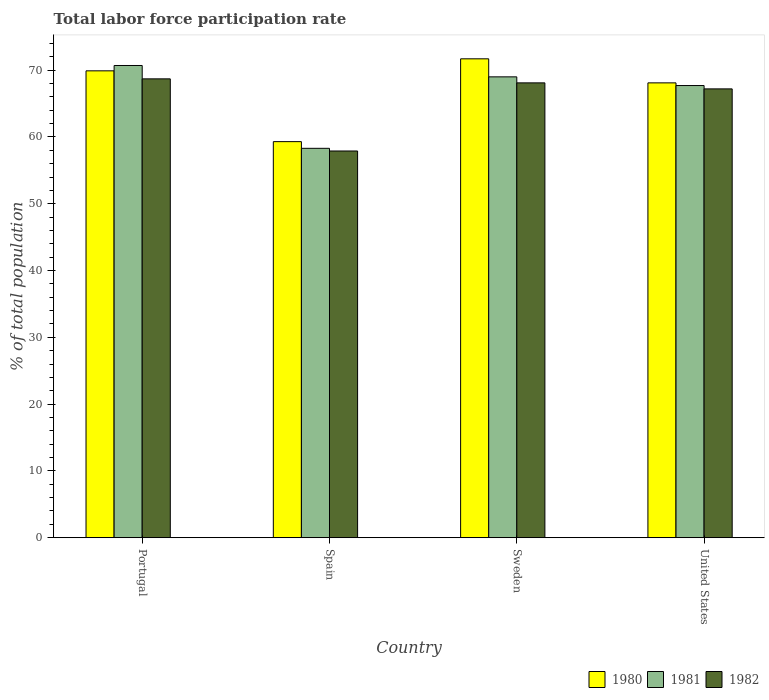How many bars are there on the 4th tick from the right?
Keep it short and to the point. 3. What is the label of the 2nd group of bars from the left?
Your response must be concise. Spain. What is the total labor force participation rate in 1980 in Portugal?
Offer a terse response. 69.9. Across all countries, what is the maximum total labor force participation rate in 1980?
Offer a very short reply. 71.7. Across all countries, what is the minimum total labor force participation rate in 1980?
Keep it short and to the point. 59.3. In which country was the total labor force participation rate in 1980 minimum?
Your answer should be compact. Spain. What is the total total labor force participation rate in 1981 in the graph?
Give a very brief answer. 265.7. What is the difference between the total labor force participation rate in 1980 in Sweden and that in United States?
Make the answer very short. 3.6. What is the difference between the total labor force participation rate in 1980 in Portugal and the total labor force participation rate in 1982 in United States?
Provide a succinct answer. 2.7. What is the average total labor force participation rate in 1981 per country?
Make the answer very short. 66.42. What is the difference between the total labor force participation rate of/in 1980 and total labor force participation rate of/in 1982 in United States?
Make the answer very short. 0.9. In how many countries, is the total labor force participation rate in 1982 greater than 26 %?
Your answer should be compact. 4. What is the ratio of the total labor force participation rate in 1980 in Portugal to that in Sweden?
Make the answer very short. 0.97. Is the total labor force participation rate in 1982 in Spain less than that in United States?
Offer a terse response. Yes. Is the difference between the total labor force participation rate in 1980 in Spain and United States greater than the difference between the total labor force participation rate in 1982 in Spain and United States?
Your answer should be compact. Yes. What is the difference between the highest and the second highest total labor force participation rate in 1980?
Give a very brief answer. -1.8. What is the difference between the highest and the lowest total labor force participation rate in 1982?
Offer a terse response. 10.8. In how many countries, is the total labor force participation rate in 1980 greater than the average total labor force participation rate in 1980 taken over all countries?
Make the answer very short. 3. Is the sum of the total labor force participation rate in 1981 in Spain and Sweden greater than the maximum total labor force participation rate in 1980 across all countries?
Your answer should be compact. Yes. What does the 3rd bar from the left in Portugal represents?
Your answer should be compact. 1982. What does the 2nd bar from the right in United States represents?
Your response must be concise. 1981. How many bars are there?
Provide a succinct answer. 12. How many countries are there in the graph?
Ensure brevity in your answer.  4. What is the difference between two consecutive major ticks on the Y-axis?
Provide a short and direct response. 10. Are the values on the major ticks of Y-axis written in scientific E-notation?
Ensure brevity in your answer.  No. Does the graph contain any zero values?
Your answer should be compact. No. Does the graph contain grids?
Your response must be concise. No. How are the legend labels stacked?
Offer a very short reply. Horizontal. What is the title of the graph?
Ensure brevity in your answer.  Total labor force participation rate. What is the label or title of the X-axis?
Give a very brief answer. Country. What is the label or title of the Y-axis?
Offer a very short reply. % of total population. What is the % of total population in 1980 in Portugal?
Provide a short and direct response. 69.9. What is the % of total population in 1981 in Portugal?
Give a very brief answer. 70.7. What is the % of total population of 1982 in Portugal?
Make the answer very short. 68.7. What is the % of total population in 1980 in Spain?
Provide a succinct answer. 59.3. What is the % of total population of 1981 in Spain?
Ensure brevity in your answer.  58.3. What is the % of total population of 1982 in Spain?
Give a very brief answer. 57.9. What is the % of total population in 1980 in Sweden?
Make the answer very short. 71.7. What is the % of total population in 1981 in Sweden?
Provide a succinct answer. 69. What is the % of total population of 1982 in Sweden?
Your answer should be very brief. 68.1. What is the % of total population in 1980 in United States?
Offer a very short reply. 68.1. What is the % of total population in 1981 in United States?
Provide a succinct answer. 67.7. What is the % of total population of 1982 in United States?
Ensure brevity in your answer.  67.2. Across all countries, what is the maximum % of total population in 1980?
Your answer should be very brief. 71.7. Across all countries, what is the maximum % of total population in 1981?
Keep it short and to the point. 70.7. Across all countries, what is the maximum % of total population in 1982?
Your answer should be very brief. 68.7. Across all countries, what is the minimum % of total population of 1980?
Provide a short and direct response. 59.3. Across all countries, what is the minimum % of total population of 1981?
Provide a short and direct response. 58.3. Across all countries, what is the minimum % of total population of 1982?
Your answer should be very brief. 57.9. What is the total % of total population in 1980 in the graph?
Offer a very short reply. 269. What is the total % of total population in 1981 in the graph?
Keep it short and to the point. 265.7. What is the total % of total population in 1982 in the graph?
Your answer should be compact. 261.9. What is the difference between the % of total population in 1980 in Portugal and that in Spain?
Offer a very short reply. 10.6. What is the difference between the % of total population of 1981 in Portugal and that in Spain?
Your answer should be very brief. 12.4. What is the difference between the % of total population in 1982 in Portugal and that in Spain?
Make the answer very short. 10.8. What is the difference between the % of total population of 1980 in Portugal and that in United States?
Your answer should be very brief. 1.8. What is the difference between the % of total population in 1981 in Portugal and that in United States?
Give a very brief answer. 3. What is the difference between the % of total population in 1982 in Portugal and that in United States?
Provide a succinct answer. 1.5. What is the difference between the % of total population of 1980 in Spain and that in Sweden?
Offer a very short reply. -12.4. What is the difference between the % of total population of 1981 in Spain and that in Sweden?
Ensure brevity in your answer.  -10.7. What is the difference between the % of total population of 1982 in Spain and that in Sweden?
Offer a terse response. -10.2. What is the difference between the % of total population of 1982 in Spain and that in United States?
Make the answer very short. -9.3. What is the difference between the % of total population in 1980 in Sweden and that in United States?
Ensure brevity in your answer.  3.6. What is the difference between the % of total population of 1981 in Sweden and that in United States?
Give a very brief answer. 1.3. What is the difference between the % of total population of 1980 in Portugal and the % of total population of 1981 in Spain?
Provide a short and direct response. 11.6. What is the difference between the % of total population of 1980 in Portugal and the % of total population of 1982 in Spain?
Provide a short and direct response. 12. What is the difference between the % of total population of 1980 in Portugal and the % of total population of 1982 in Sweden?
Your answer should be compact. 1.8. What is the difference between the % of total population in 1981 in Portugal and the % of total population in 1982 in Sweden?
Offer a terse response. 2.6. What is the difference between the % of total population of 1980 in Portugal and the % of total population of 1982 in United States?
Your answer should be very brief. 2.7. What is the difference between the % of total population in 1980 in Spain and the % of total population in 1981 in Sweden?
Provide a short and direct response. -9.7. What is the difference between the % of total population of 1980 in Spain and the % of total population of 1982 in United States?
Offer a terse response. -7.9. What is the average % of total population in 1980 per country?
Offer a very short reply. 67.25. What is the average % of total population of 1981 per country?
Keep it short and to the point. 66.42. What is the average % of total population in 1982 per country?
Keep it short and to the point. 65.47. What is the difference between the % of total population of 1980 and % of total population of 1981 in Portugal?
Ensure brevity in your answer.  -0.8. What is the difference between the % of total population of 1980 and % of total population of 1982 in Spain?
Provide a succinct answer. 1.4. What is the difference between the % of total population in 1980 and % of total population in 1981 in Sweden?
Your response must be concise. 2.7. What is the difference between the % of total population of 1980 and % of total population of 1982 in Sweden?
Give a very brief answer. 3.6. What is the difference between the % of total population of 1980 and % of total population of 1982 in United States?
Your answer should be compact. 0.9. What is the difference between the % of total population in 1981 and % of total population in 1982 in United States?
Ensure brevity in your answer.  0.5. What is the ratio of the % of total population of 1980 in Portugal to that in Spain?
Ensure brevity in your answer.  1.18. What is the ratio of the % of total population in 1981 in Portugal to that in Spain?
Make the answer very short. 1.21. What is the ratio of the % of total population of 1982 in Portugal to that in Spain?
Provide a succinct answer. 1.19. What is the ratio of the % of total population of 1980 in Portugal to that in Sweden?
Offer a very short reply. 0.97. What is the ratio of the % of total population in 1981 in Portugal to that in Sweden?
Offer a terse response. 1.02. What is the ratio of the % of total population in 1982 in Portugal to that in Sweden?
Your answer should be very brief. 1.01. What is the ratio of the % of total population of 1980 in Portugal to that in United States?
Ensure brevity in your answer.  1.03. What is the ratio of the % of total population in 1981 in Portugal to that in United States?
Make the answer very short. 1.04. What is the ratio of the % of total population in 1982 in Portugal to that in United States?
Offer a very short reply. 1.02. What is the ratio of the % of total population of 1980 in Spain to that in Sweden?
Your answer should be compact. 0.83. What is the ratio of the % of total population in 1981 in Spain to that in Sweden?
Offer a very short reply. 0.84. What is the ratio of the % of total population of 1982 in Spain to that in Sweden?
Offer a very short reply. 0.85. What is the ratio of the % of total population in 1980 in Spain to that in United States?
Your answer should be very brief. 0.87. What is the ratio of the % of total population in 1981 in Spain to that in United States?
Offer a terse response. 0.86. What is the ratio of the % of total population of 1982 in Spain to that in United States?
Offer a terse response. 0.86. What is the ratio of the % of total population in 1980 in Sweden to that in United States?
Provide a succinct answer. 1.05. What is the ratio of the % of total population of 1981 in Sweden to that in United States?
Provide a succinct answer. 1.02. What is the ratio of the % of total population in 1982 in Sweden to that in United States?
Keep it short and to the point. 1.01. What is the difference between the highest and the second highest % of total population in 1981?
Make the answer very short. 1.7. What is the difference between the highest and the lowest % of total population of 1981?
Your answer should be compact. 12.4. 